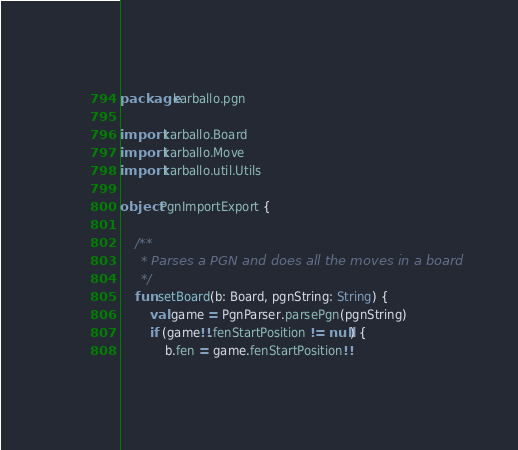Convert code to text. <code><loc_0><loc_0><loc_500><loc_500><_Kotlin_>package karballo.pgn

import karballo.Board
import karballo.Move
import karballo.util.Utils

object PgnImportExport {

    /**
     * Parses a PGN and does all the moves in a board
     */
    fun setBoard(b: Board, pgnString: String) {
        val game = PgnParser.parsePgn(pgnString)
        if (game!!.fenStartPosition != null) {
            b.fen = game.fenStartPosition!!</code> 